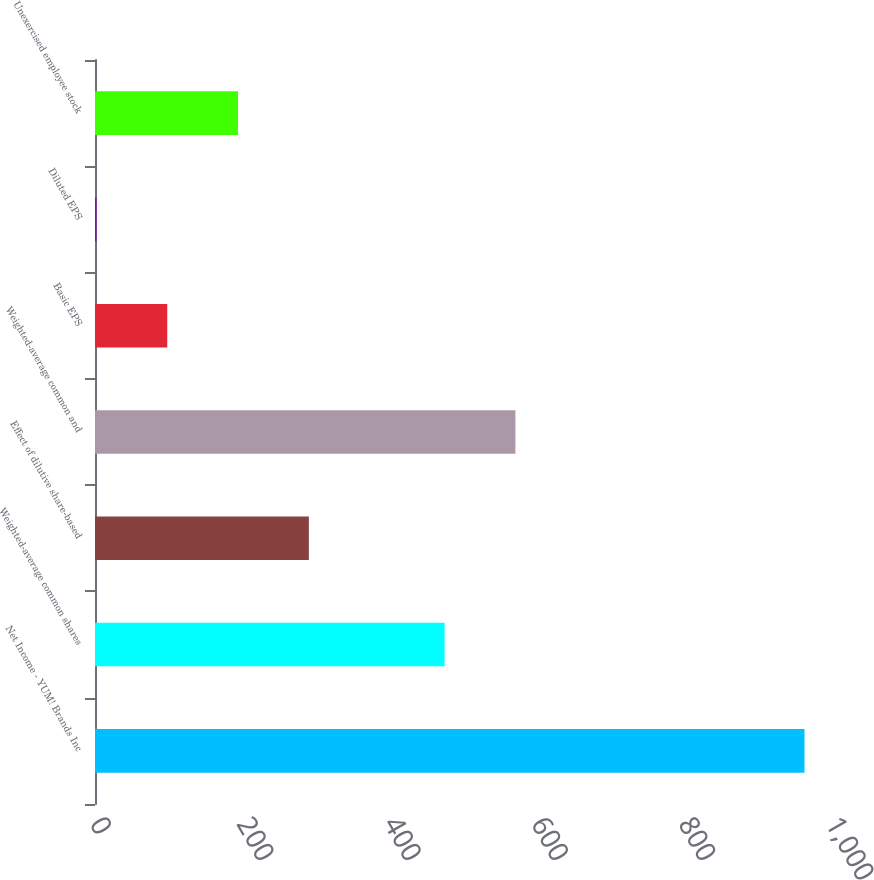Convert chart. <chart><loc_0><loc_0><loc_500><loc_500><bar_chart><fcel>Net Income - YUM! Brands Inc<fcel>Weighted-average common shares<fcel>Effect of dilutive share-based<fcel>Weighted-average common and<fcel>Basic EPS<fcel>Diluted EPS<fcel>Unexercised employee stock<nl><fcel>964<fcel>475<fcel>290.56<fcel>571.2<fcel>98.16<fcel>1.96<fcel>194.36<nl></chart> 